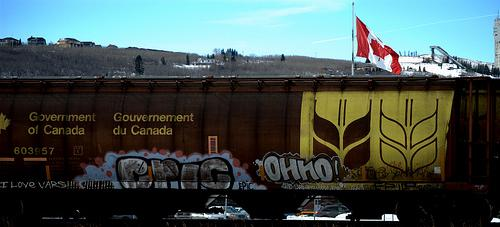Mention the most visually captivating elements within the image. The brown and yellow train with striking graffiti, Canadian markings, and the contrasting red and white waving Canadian flag in the foreground are quite captivating. Describe how the landscape looks in the background of the image. In the background, there are snow-covered hills with trees, ancient buildings on top, a hillside with houses, and a vivid blue sky with clouds. What are the dominant colors and objects present in the image? The dominant colors are brown, yellow, red, and white, featuring objects like train, Canadian flag, graffiti, snowy hills, buildings, and trees. Express your impression of the scene depicted in the image. The scene feels like a moment captured in time, where a train embellished with graffiti and Canadian symbols rests while surrounded by a picturesque snowy landscape. Provide a brief summary of the central components of this image. A brown and yellow train with graffiti and Canadian government markings is parked beside a red and white Canadian flag, with snowy hills and buildings in the background. Highlight the key features of the train and its surroundings in the image. The train has white and black graffiti, yellow Government of Canada markings, and an illustration. It's surrounded by a Canadian flag, snow-covered hills, trees, and buildings. Describe the image in a poetic manner, highlighting the main aspects. Amidst a canvas of blue skies and snow-dusted hills, rests a train adorned with tales of colors, Canadian spirit, and whispers of wheat, waving alongside the proud red and white flag. Detail three objects with their respective colors as seen in the image. A brown and yellow train, a red and white Canadian flag, and a blue sky with white clouds can be seen in the image. Put emphasis on the presence of nature and landscape elements in the image. The image features beautiful natural elements such as snow-covered hills, trees on the hillside, a blue sky with clouds, and ancient buildings in the background. Mention the primary mode of transportation and its distinguishing features in the image. The primary mode of transportation is the brown and yellow train with graffiti, Canadian government markings, and a yellow wheat illustration. 